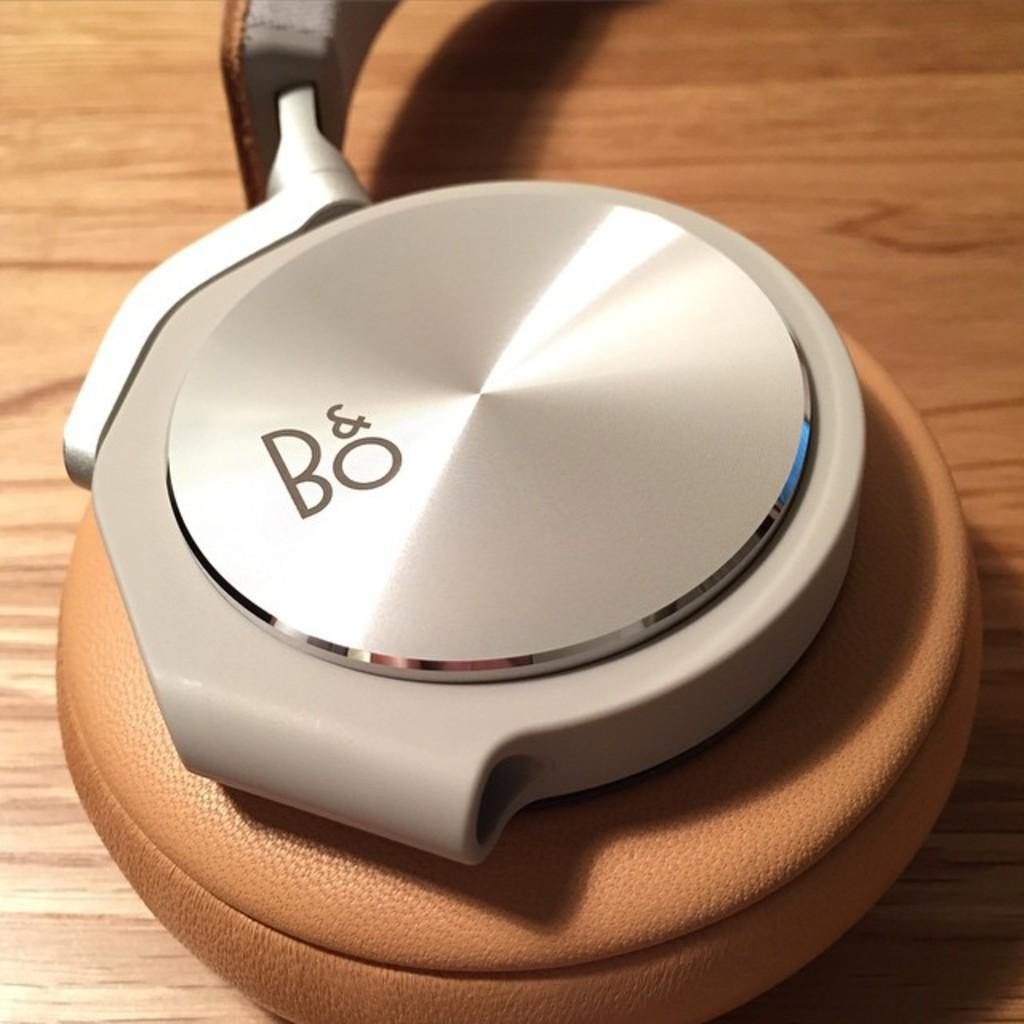<image>
Summarize the visual content of the image. A pair of tan headphones that say B&O on the ear piece. 